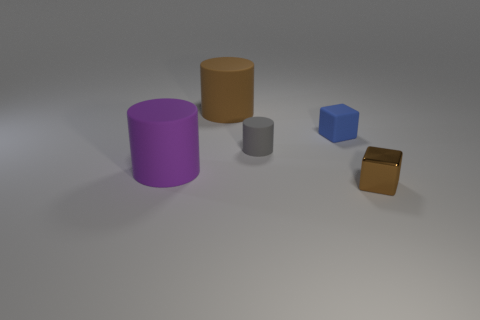Subtract all gray rubber cylinders. How many cylinders are left? 2 Add 2 big cyan matte spheres. How many objects exist? 7 Subtract 1 cubes. How many cubes are left? 1 Add 3 tiny brown shiny cubes. How many tiny brown shiny cubes are left? 4 Add 3 metallic spheres. How many metallic spheres exist? 3 Subtract all gray cylinders. How many cylinders are left? 2 Subtract 1 gray cylinders. How many objects are left? 4 Subtract all blocks. How many objects are left? 3 Subtract all cyan cylinders. Subtract all green cubes. How many cylinders are left? 3 Subtract all green balls. How many red cylinders are left? 0 